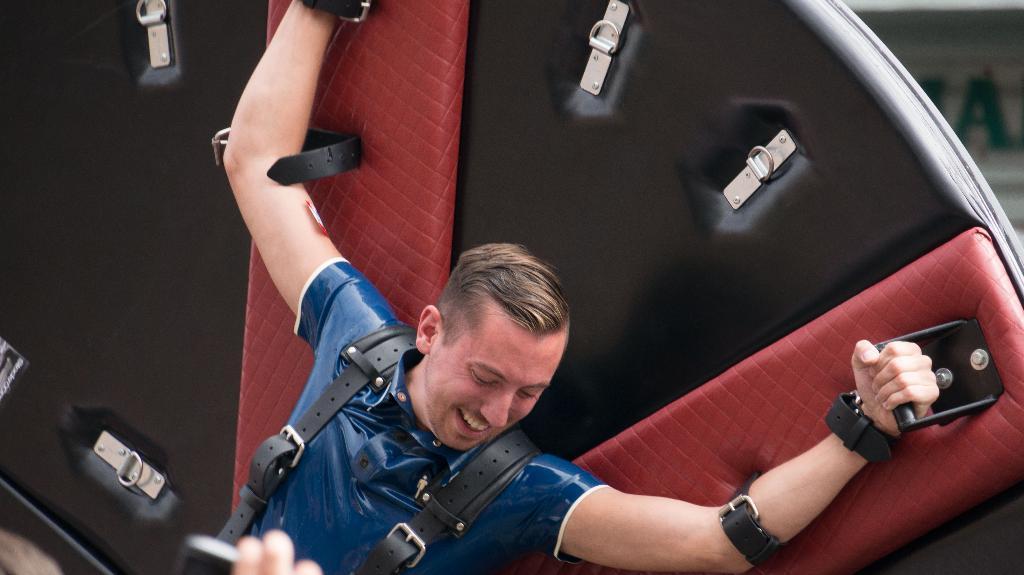How would you summarize this image in a sentence or two? In this image, we can see a man wearing belts and holding a rod of an object. In the top right corner, we can see the text. At the bottom of the image, we can see the fingers of a person holding an object.  